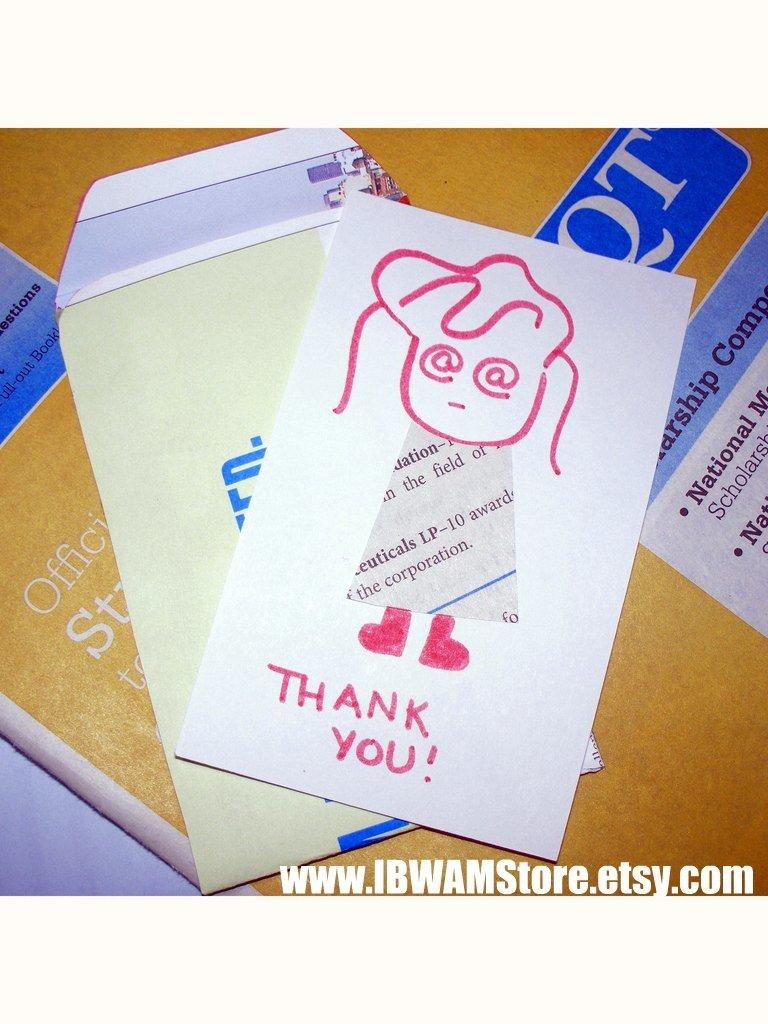Provide a one-sentence caption for the provided image. A hand drawn Thank You note depicting a girl with a newspaper dress. 